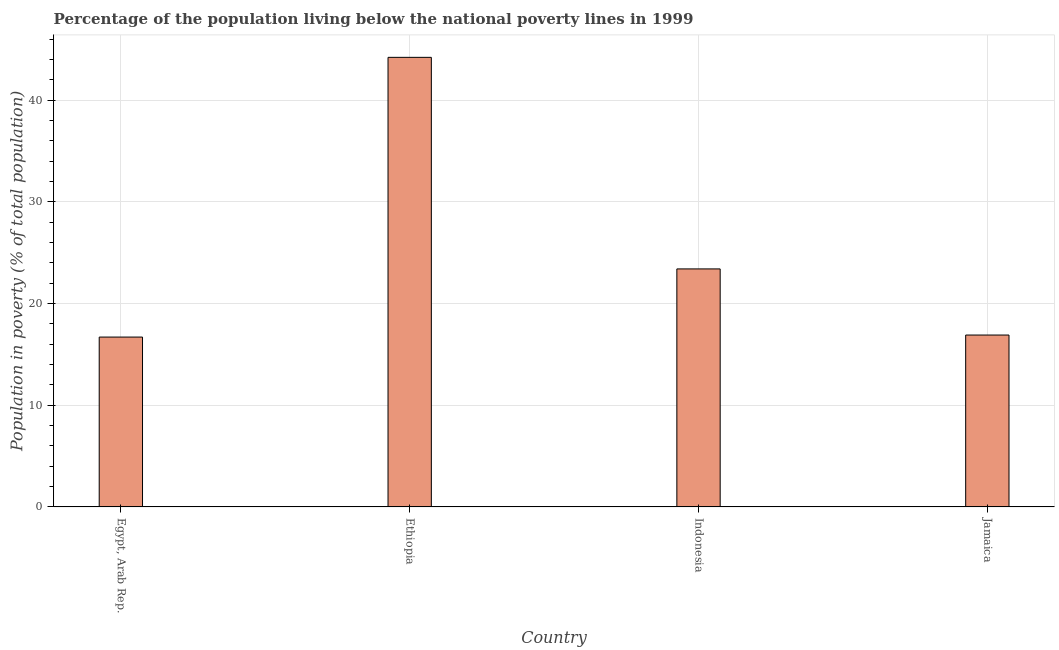Does the graph contain any zero values?
Keep it short and to the point. No. What is the title of the graph?
Ensure brevity in your answer.  Percentage of the population living below the national poverty lines in 1999. What is the label or title of the X-axis?
Give a very brief answer. Country. What is the label or title of the Y-axis?
Offer a very short reply. Population in poverty (% of total population). What is the percentage of population living below poverty line in Ethiopia?
Provide a succinct answer. 44.2. Across all countries, what is the maximum percentage of population living below poverty line?
Offer a terse response. 44.2. In which country was the percentage of population living below poverty line maximum?
Your answer should be very brief. Ethiopia. In which country was the percentage of population living below poverty line minimum?
Offer a very short reply. Egypt, Arab Rep. What is the sum of the percentage of population living below poverty line?
Ensure brevity in your answer.  101.2. What is the difference between the percentage of population living below poverty line in Indonesia and Jamaica?
Offer a very short reply. 6.5. What is the average percentage of population living below poverty line per country?
Offer a very short reply. 25.3. What is the median percentage of population living below poverty line?
Give a very brief answer. 20.15. What is the ratio of the percentage of population living below poverty line in Ethiopia to that in Indonesia?
Make the answer very short. 1.89. What is the difference between the highest and the second highest percentage of population living below poverty line?
Your response must be concise. 20.8. Is the sum of the percentage of population living below poverty line in Egypt, Arab Rep. and Indonesia greater than the maximum percentage of population living below poverty line across all countries?
Offer a very short reply. No. Are all the bars in the graph horizontal?
Your answer should be very brief. No. How many countries are there in the graph?
Offer a very short reply. 4. What is the difference between two consecutive major ticks on the Y-axis?
Make the answer very short. 10. What is the Population in poverty (% of total population) of Egypt, Arab Rep.?
Give a very brief answer. 16.7. What is the Population in poverty (% of total population) of Ethiopia?
Give a very brief answer. 44.2. What is the Population in poverty (% of total population) of Indonesia?
Your answer should be very brief. 23.4. What is the Population in poverty (% of total population) of Jamaica?
Ensure brevity in your answer.  16.9. What is the difference between the Population in poverty (% of total population) in Egypt, Arab Rep. and Ethiopia?
Provide a short and direct response. -27.5. What is the difference between the Population in poverty (% of total population) in Egypt, Arab Rep. and Jamaica?
Provide a short and direct response. -0.2. What is the difference between the Population in poverty (% of total population) in Ethiopia and Indonesia?
Provide a short and direct response. 20.8. What is the difference between the Population in poverty (% of total population) in Ethiopia and Jamaica?
Ensure brevity in your answer.  27.3. What is the difference between the Population in poverty (% of total population) in Indonesia and Jamaica?
Your answer should be very brief. 6.5. What is the ratio of the Population in poverty (% of total population) in Egypt, Arab Rep. to that in Ethiopia?
Ensure brevity in your answer.  0.38. What is the ratio of the Population in poverty (% of total population) in Egypt, Arab Rep. to that in Indonesia?
Give a very brief answer. 0.71. What is the ratio of the Population in poverty (% of total population) in Ethiopia to that in Indonesia?
Keep it short and to the point. 1.89. What is the ratio of the Population in poverty (% of total population) in Ethiopia to that in Jamaica?
Offer a terse response. 2.62. What is the ratio of the Population in poverty (% of total population) in Indonesia to that in Jamaica?
Make the answer very short. 1.39. 